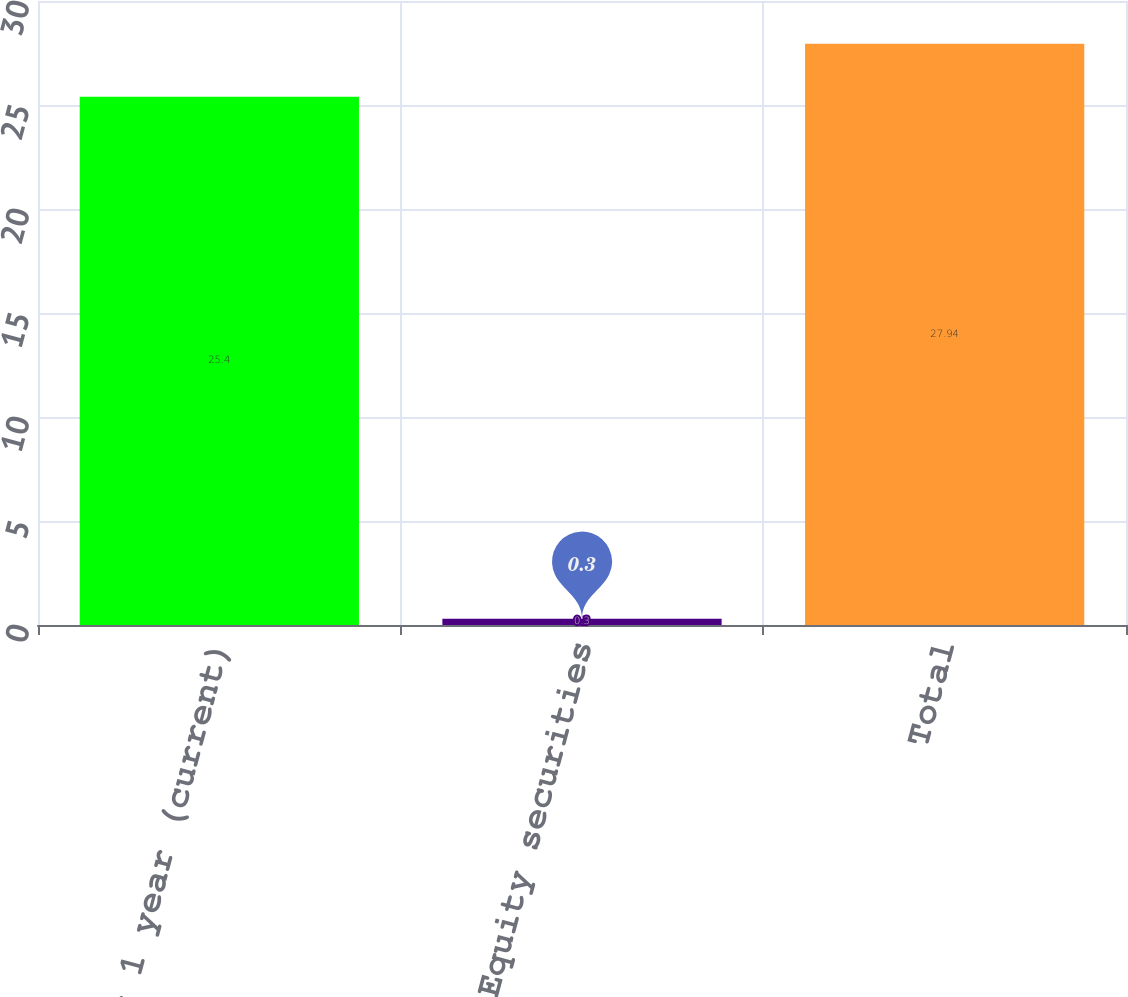Convert chart to OTSL. <chart><loc_0><loc_0><loc_500><loc_500><bar_chart><fcel>Under 1 year (current)<fcel>Equity securities<fcel>Total<nl><fcel>25.4<fcel>0.3<fcel>27.94<nl></chart> 